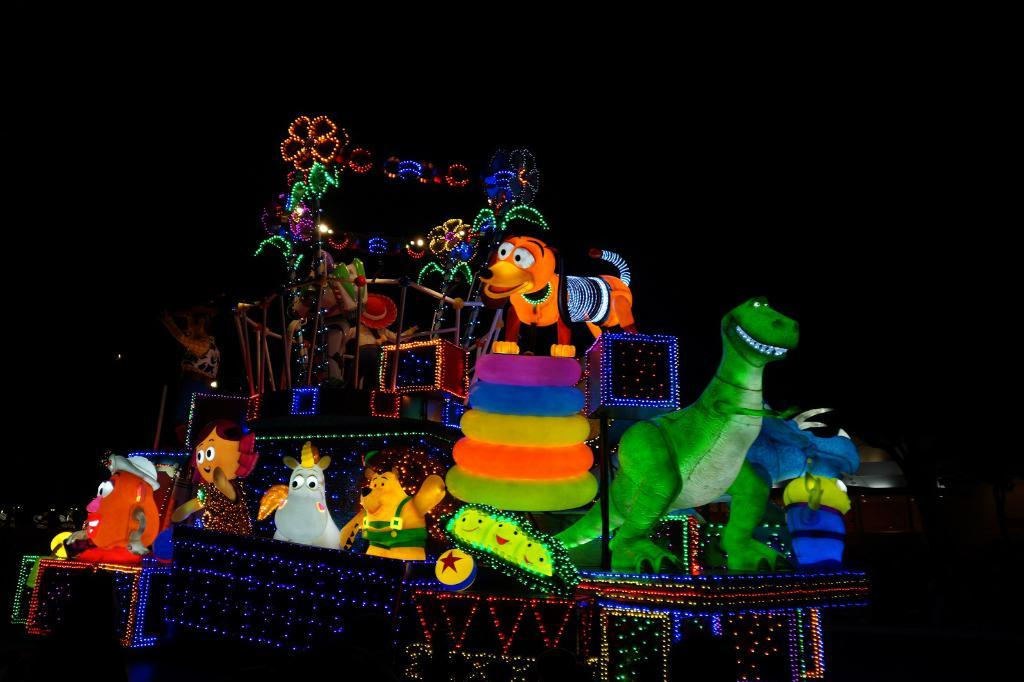What time of day is depicted in the image? The image was taken during night time. What types of objects can be seen in the image? There are different types of toys in the image. What weather condition is present in the image? There is lightning in the image. How many fingers can be seen holding the spoon in the image? There is no spoon present in the image, so it is not possible to determine the number of fingers holding it. 